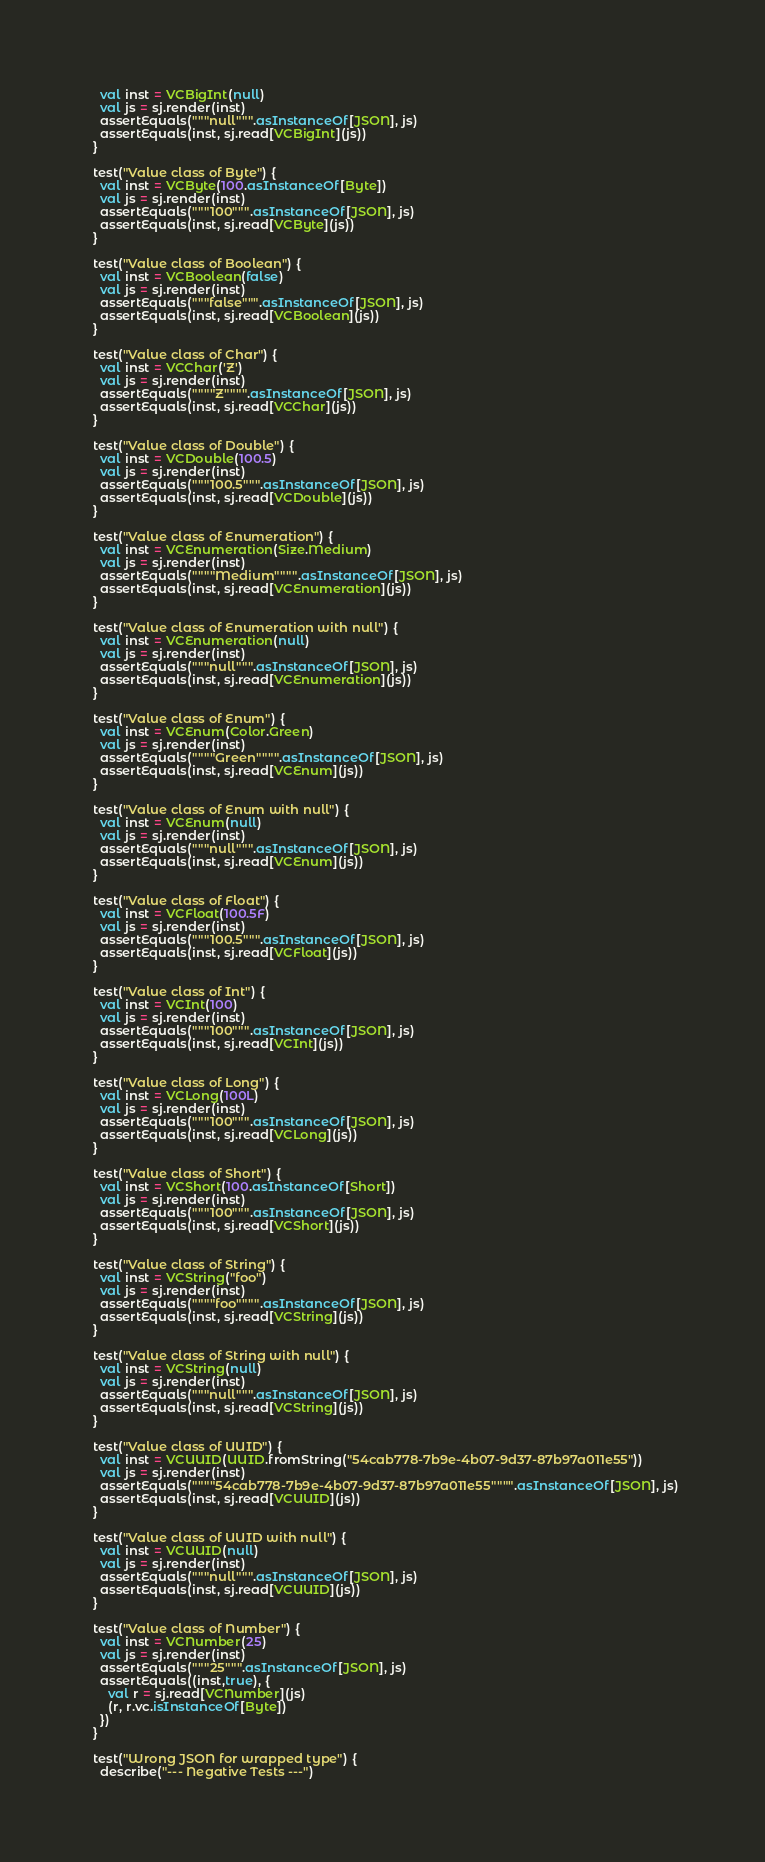Convert code to text. <code><loc_0><loc_0><loc_500><loc_500><_Scala_>    val inst = VCBigInt(null)
    val js = sj.render(inst)
    assertEquals("""null""".asInstanceOf[JSON], js)
    assertEquals(inst, sj.read[VCBigInt](js))
  }

  test("Value class of Byte") {
    val inst = VCByte(100.asInstanceOf[Byte])
    val js = sj.render(inst)
    assertEquals("""100""".asInstanceOf[JSON], js)
    assertEquals(inst, sj.read[VCByte](js))
  }

  test("Value class of Boolean") {
    val inst = VCBoolean(false)
    val js = sj.render(inst)
    assertEquals("""false""".asInstanceOf[JSON], js)
    assertEquals(inst, sj.read[VCBoolean](js))
  }

  test("Value class of Char") {
    val inst = VCChar('Z')
    val js = sj.render(inst)
    assertEquals(""""Z"""".asInstanceOf[JSON], js)
    assertEquals(inst, sj.read[VCChar](js))
  }

  test("Value class of Double") {
    val inst = VCDouble(100.5)
    val js = sj.render(inst)
    assertEquals("""100.5""".asInstanceOf[JSON], js)
    assertEquals(inst, sj.read[VCDouble](js))
  }

  test("Value class of Enumeration") {
    val inst = VCEnumeration(Size.Medium)
    val js = sj.render(inst)
    assertEquals(""""Medium"""".asInstanceOf[JSON], js)
    assertEquals(inst, sj.read[VCEnumeration](js))
  }

  test("Value class of Enumeration with null") {
    val inst = VCEnumeration(null)
    val js = sj.render(inst)
    assertEquals("""null""".asInstanceOf[JSON], js)
    assertEquals(inst, sj.read[VCEnumeration](js))
  }

  test("Value class of Enum") {
    val inst = VCEnum(Color.Green)
    val js = sj.render(inst)
    assertEquals(""""Green"""".asInstanceOf[JSON], js)
    assertEquals(inst, sj.read[VCEnum](js))
  }

  test("Value class of Enum with null") {
    val inst = VCEnum(null)
    val js = sj.render(inst)
    assertEquals("""null""".asInstanceOf[JSON], js)
    assertEquals(inst, sj.read[VCEnum](js))
  }

  test("Value class of Float") {
    val inst = VCFloat(100.5F)
    val js = sj.render(inst)
    assertEquals("""100.5""".asInstanceOf[JSON], js)
    assertEquals(inst, sj.read[VCFloat](js))
  }

  test("Value class of Int") {
    val inst = VCInt(100)
    val js = sj.render(inst)
    assertEquals("""100""".asInstanceOf[JSON], js)
    assertEquals(inst, sj.read[VCInt](js))
  }

  test("Value class of Long") {
    val inst = VCLong(100L)
    val js = sj.render(inst)
    assertEquals("""100""".asInstanceOf[JSON], js)
    assertEquals(inst, sj.read[VCLong](js))
  }

  test("Value class of Short") {
    val inst = VCShort(100.asInstanceOf[Short])
    val js = sj.render(inst)
    assertEquals("""100""".asInstanceOf[JSON], js)
    assertEquals(inst, sj.read[VCShort](js))
  }

  test("Value class of String") {
    val inst = VCString("foo")
    val js = sj.render(inst)
    assertEquals(""""foo"""".asInstanceOf[JSON], js)
    assertEquals(inst, sj.read[VCString](js))
  }

  test("Value class of String with null") {
    val inst = VCString(null)
    val js = sj.render(inst)
    assertEquals("""null""".asInstanceOf[JSON], js)
    assertEquals(inst, sj.read[VCString](js))
  }

  test("Value class of UUID") {
    val inst = VCUUID(UUID.fromString("54cab778-7b9e-4b07-9d37-87b97a011e55"))
    val js = sj.render(inst)
    assertEquals(""""54cab778-7b9e-4b07-9d37-87b97a011e55"""".asInstanceOf[JSON], js)
    assertEquals(inst, sj.read[VCUUID](js))
  }

  test("Value class of UUID with null") {
    val inst = VCUUID(null)
    val js = sj.render(inst)
    assertEquals("""null""".asInstanceOf[JSON], js)
    assertEquals(inst, sj.read[VCUUID](js))
  }

  test("Value class of Number") {
    val inst = VCNumber(25)
    val js = sj.render(inst)
    assertEquals("""25""".asInstanceOf[JSON], js)
    assertEquals((inst,true), {
      val r = sj.read[VCNumber](js)
      (r, r.vc.isInstanceOf[Byte])
    })
  }

  test("Wrong JSON for wrapped type") {
    describe("--- Negative Tests ---")
</code> 